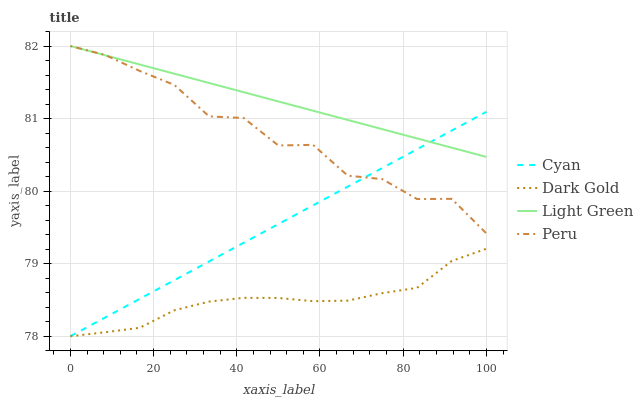Does Dark Gold have the minimum area under the curve?
Answer yes or no. Yes. Does Light Green have the maximum area under the curve?
Answer yes or no. Yes. Does Peru have the minimum area under the curve?
Answer yes or no. No. Does Peru have the maximum area under the curve?
Answer yes or no. No. Is Cyan the smoothest?
Answer yes or no. Yes. Is Peru the roughest?
Answer yes or no. Yes. Is Light Green the smoothest?
Answer yes or no. No. Is Light Green the roughest?
Answer yes or no. No. Does Cyan have the lowest value?
Answer yes or no. Yes. Does Peru have the lowest value?
Answer yes or no. No. Does Light Green have the highest value?
Answer yes or no. Yes. Does Dark Gold have the highest value?
Answer yes or no. No. Is Dark Gold less than Peru?
Answer yes or no. Yes. Is Light Green greater than Dark Gold?
Answer yes or no. Yes. Does Light Green intersect Cyan?
Answer yes or no. Yes. Is Light Green less than Cyan?
Answer yes or no. No. Is Light Green greater than Cyan?
Answer yes or no. No. Does Dark Gold intersect Peru?
Answer yes or no. No. 